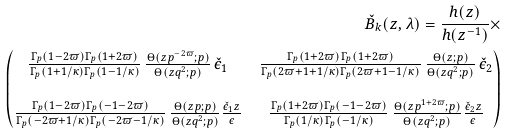<formula> <loc_0><loc_0><loc_500><loc_500>\check { B } _ { k } ( z , \lambda ) = \frac { h ( z ) } { h ( z ^ { - 1 } ) } \times \\ \begin{pmatrix} \frac { \Gamma _ { p } ( 1 - 2 \varpi ) \Gamma _ { p } ( 1 + 2 \varpi ) } { \Gamma _ { p } ( 1 + 1 / \kappa ) \Gamma _ { p } ( 1 - 1 / \kappa ) } \, \frac { \Theta ( z p ^ { - 2 \varpi } ; p ) } { \Theta ( z q ^ { 2 } ; p ) } \, \check { \epsilon } _ { 1 } & \frac { \Gamma _ { p } ( 1 + 2 \varpi ) \Gamma _ { p } ( 1 + 2 \varpi ) } { \Gamma _ { p } ( 2 \varpi + 1 + 1 / \kappa ) \Gamma _ { p } ( 2 \varpi + 1 - 1 / \kappa ) } \, \frac { \Theta ( z ; p ) } { \Theta ( z q ^ { 2 } ; p ) } \, \check { \epsilon } _ { 2 } \\ \\ \frac { \Gamma _ { p } ( 1 - 2 \varpi ) \Gamma _ { p } ( - 1 - 2 \varpi ) } { \Gamma _ { p } ( - 2 \varpi + 1 / \kappa ) \Gamma _ { p } ( - 2 \varpi - 1 / \kappa ) } \, \frac { \Theta ( z p ; p ) } { \Theta ( z q ^ { 2 } ; p ) } \frac { \check { \epsilon } _ { 1 } z } { \epsilon } & \frac { \Gamma _ { p } ( 1 + 2 \varpi ) \Gamma _ { p } ( - 1 - 2 \varpi ) } { \Gamma _ { p } ( 1 / \kappa ) \Gamma _ { p } ( - 1 / \kappa ) } \, \frac { \Theta ( z p ^ { 1 + 2 \varpi } ; p ) } { \Theta ( z q ^ { 2 } ; p ) } \frac { \check { \epsilon } _ { 2 } z } { \epsilon } \end{pmatrix}</formula> 